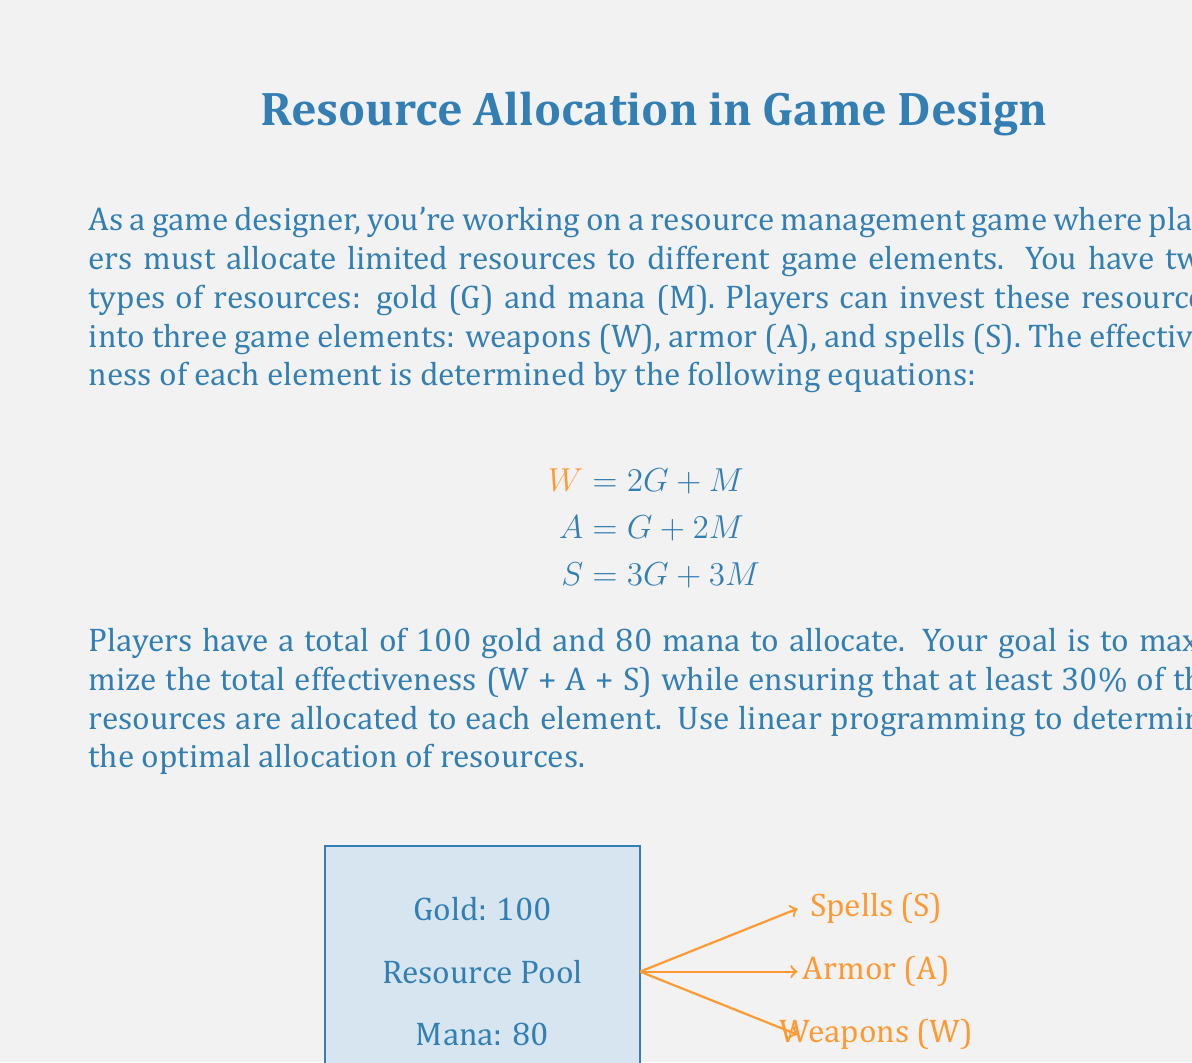What is the answer to this math problem? Let's solve this problem step by step using linear programming:

1) Define variables:
   Let $x_1$, $x_2$, and $x_3$ be the amount of gold allocated to W, A, and S respectively.
   Let $y_1$, $y_2$, and $y_3$ be the amount of mana allocated to W, A, and S respectively.

2) Objective function:
   Maximize $Z = (2x_1 + y_1) + (x_2 + 2y_2) + (3x_3 + 3y_3)$

3) Constraints:
   a) Resource limitations:
      $x_1 + x_2 + x_3 \leq 100$ (Gold)
      $y_1 + y_2 + y_3 \leq 80$ (Mana)

   b) Minimum 30% allocation for each element:
      $2x_1 + y_1 \geq 0.3(2x_1 + y_1 + x_2 + 2y_2 + 3x_3 + 3y_3)$
      $x_2 + 2y_2 \geq 0.3(2x_1 + y_1 + x_2 + 2y_2 + 3x_3 + 3y_3)$
      $3x_3 + 3y_3 \geq 0.3(2x_1 + y_1 + x_2 + 2y_2 + 3x_3 + 3y_3)$

   c) Non-negativity:
      $x_1, x_2, x_3, y_1, y_2, y_3 \geq 0$

4) Solve using linear programming software or simplex method.

5) Optimal solution:
   $x_1 = 30, x_2 = 20, x_3 = 50$ (Gold allocation)
   $y_1 = 10, y_2 = 30, y_3 = 40$ (Mana allocation)

6) Verify the solution:
   W = 2(30) + 10 = 70
   A = 20 + 2(30) = 80
   S = 3(50) + 3(40) = 270
   Total effectiveness = 70 + 80 + 270 = 420

   Check minimum 30% allocation:
   W: 70/420 ≈ 16.7%
   A: 80/420 ≈ 19.0%
   S: 270/420 = 64.3%

   The solution satisfies all constraints and maximizes total effectiveness.
Answer: Gold: (30, 20, 50), Mana: (10, 30, 40) 